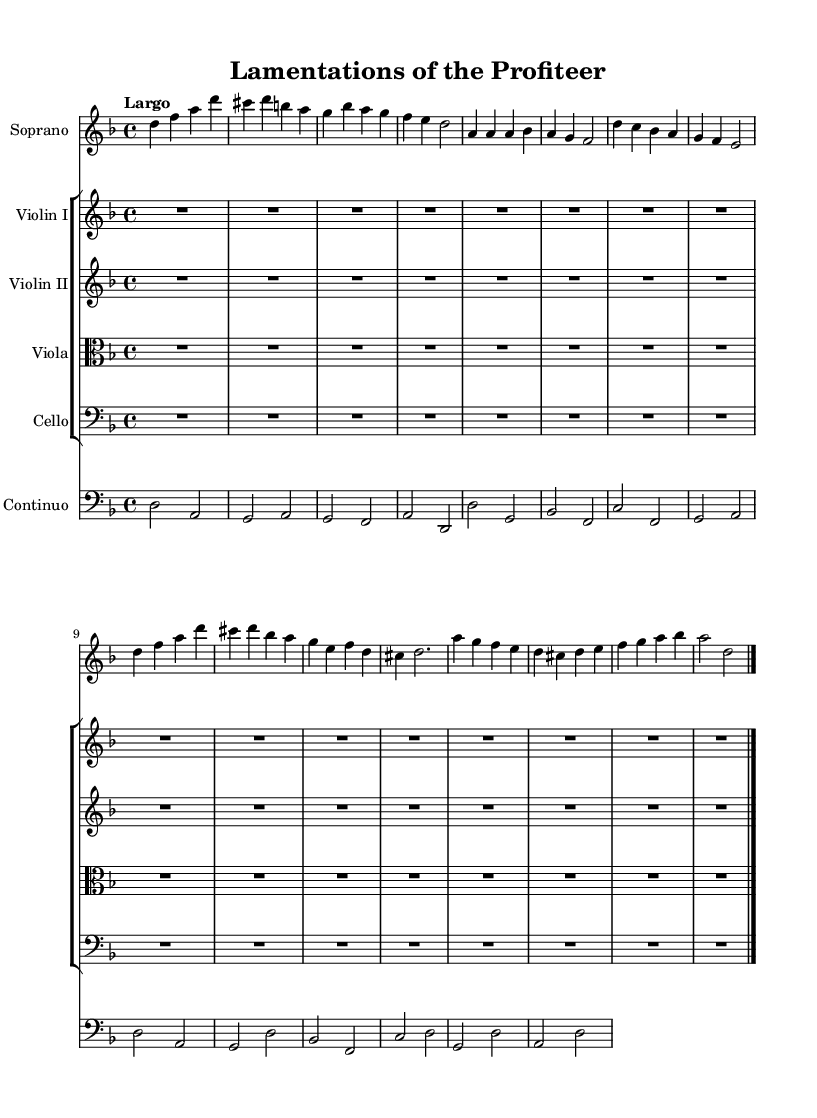What is the key signature of this music? The key signature indicates D minor, which has one flat (B flat). This can be seen at the beginning of the sheet music where the key signature symbols are placed.
Answer: D minor What is the time signature of the piece? The time signature is 4/4, which is marked at the beginning of the score. This indicates there are four beats in each measure, and the quarter note receives one beat.
Answer: 4/4 What is the tempo marking for this piece? The tempo marking is Largo, which is indicated clearly in the score. Largo is a slow tempo, generally considered to mean "broad".
Answer: Largo What is the main theme reflected in the lyrics? The lyrics express the moral implications of war profiteering, emphasizing guilt from profiting off conflict. This is inferred from phrases like "Profi - ting from the seeds of war".
Answer: War profiteering How many instruments are included in this composition? The composition features five instruments, as indicated by the staff groups for Soprano, Violin I, Violin II, Viola, and Cello. Each instrument has its own part within the score.
Answer: Five What type of musical form is represented in the score? The score indicates a combination of recitative and aria, common in Baroque sacred music, where the recitative is more speech-like and the aria is a melodic form expressing emotion. The structure reflects a blend of both forms.
Answer: Recitative and aria 